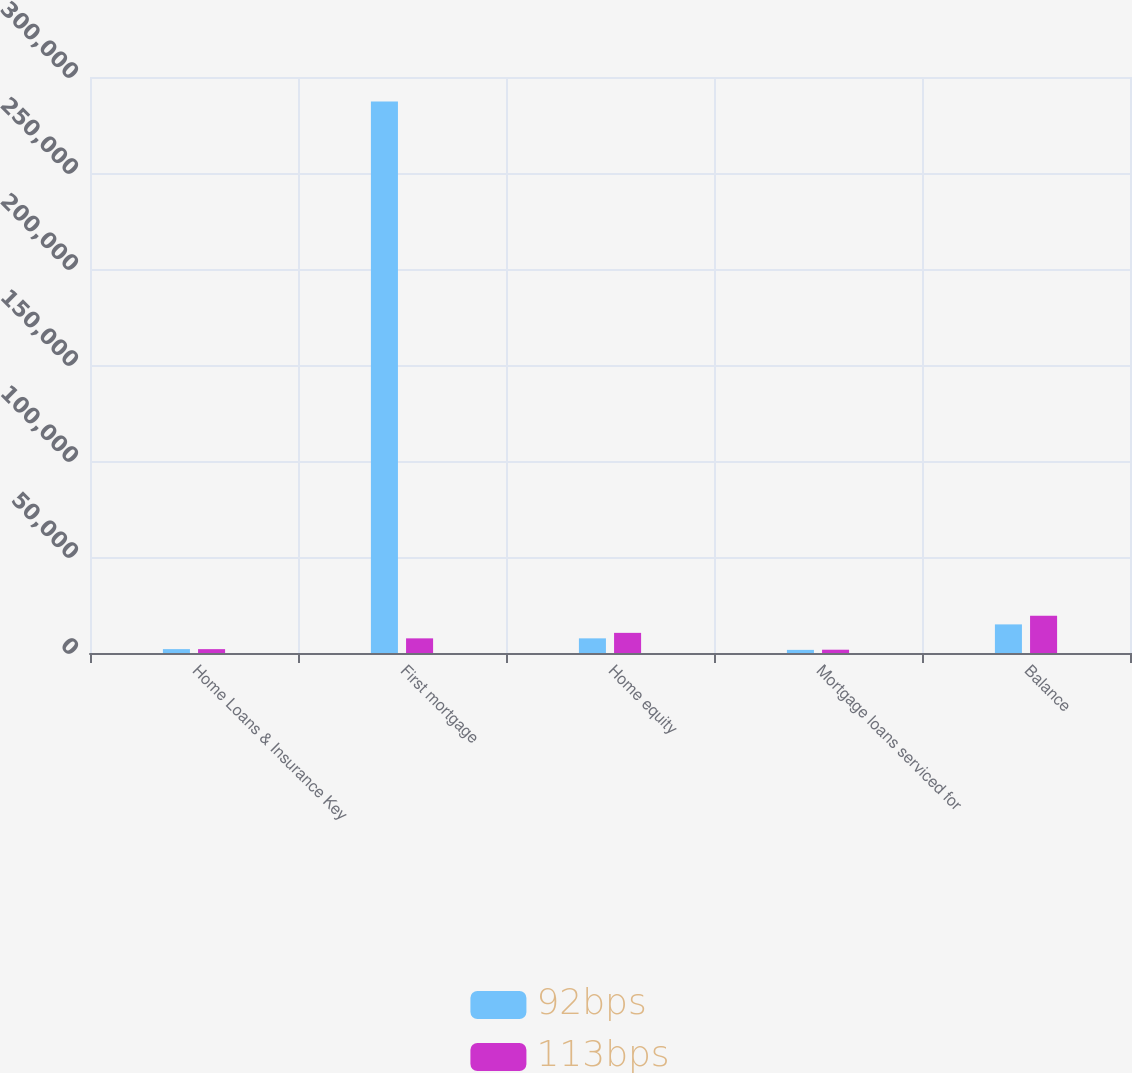Convert chart. <chart><loc_0><loc_0><loc_500><loc_500><stacked_bar_chart><ecel><fcel>Home Loans & Insurance Key<fcel>First mortgage<fcel>Home equity<fcel>Mortgage loans serviced for<fcel>Balance<nl><fcel>92bps<fcel>2010<fcel>287236<fcel>7626<fcel>1628<fcel>14900<nl><fcel>113bps<fcel>2009<fcel>7626<fcel>10488<fcel>1716<fcel>19465<nl></chart> 